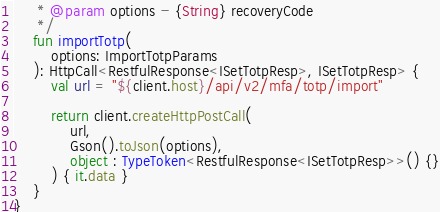<code> <loc_0><loc_0><loc_500><loc_500><_Kotlin_>     * @param options - {String} recoveryCode 
     */
    fun importTotp(
        options: ImportTotpParams
    ): HttpCall<RestfulResponse<ISetTotpResp>, ISetTotpResp> {
        val url = "${client.host}/api/v2/mfa/totp/import"

        return client.createHttpPostCall(
            url,
            Gson().toJson(options),
            object : TypeToken<RestfulResponse<ISetTotpResp>>() {}
        ) { it.data }
    }
}</code> 